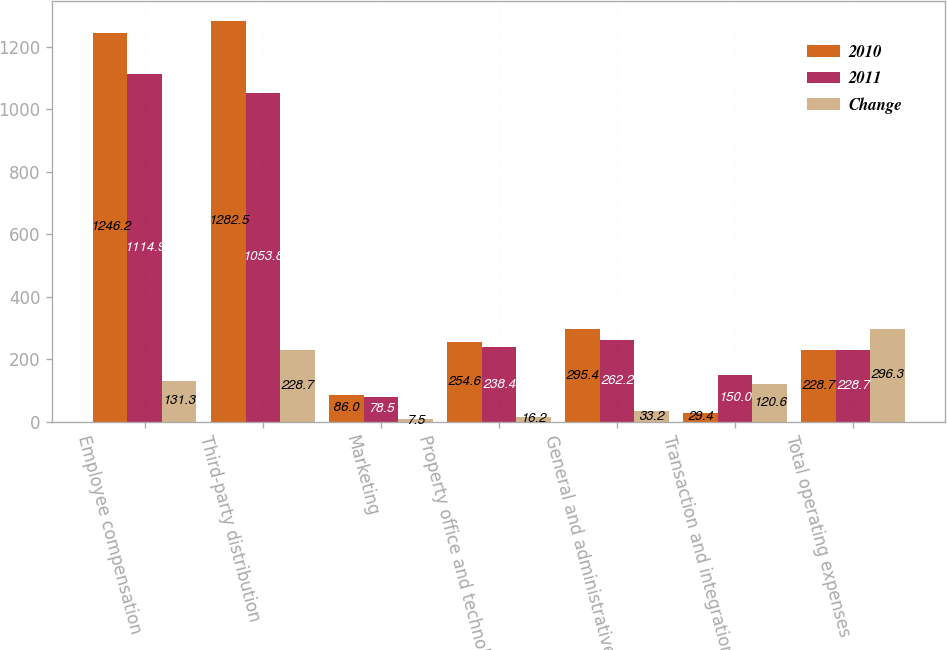<chart> <loc_0><loc_0><loc_500><loc_500><stacked_bar_chart><ecel><fcel>Employee compensation<fcel>Third-party distribution<fcel>Marketing<fcel>Property office and technology<fcel>General and administrative<fcel>Transaction and integration<fcel>Total operating expenses<nl><fcel>2010<fcel>1246.2<fcel>1282.5<fcel>86<fcel>254.6<fcel>295.4<fcel>29.4<fcel>228.7<nl><fcel>2011<fcel>1114.9<fcel>1053.8<fcel>78.5<fcel>238.4<fcel>262.2<fcel>150<fcel>228.7<nl><fcel>Change<fcel>131.3<fcel>228.7<fcel>7.5<fcel>16.2<fcel>33.2<fcel>120.6<fcel>296.3<nl></chart> 